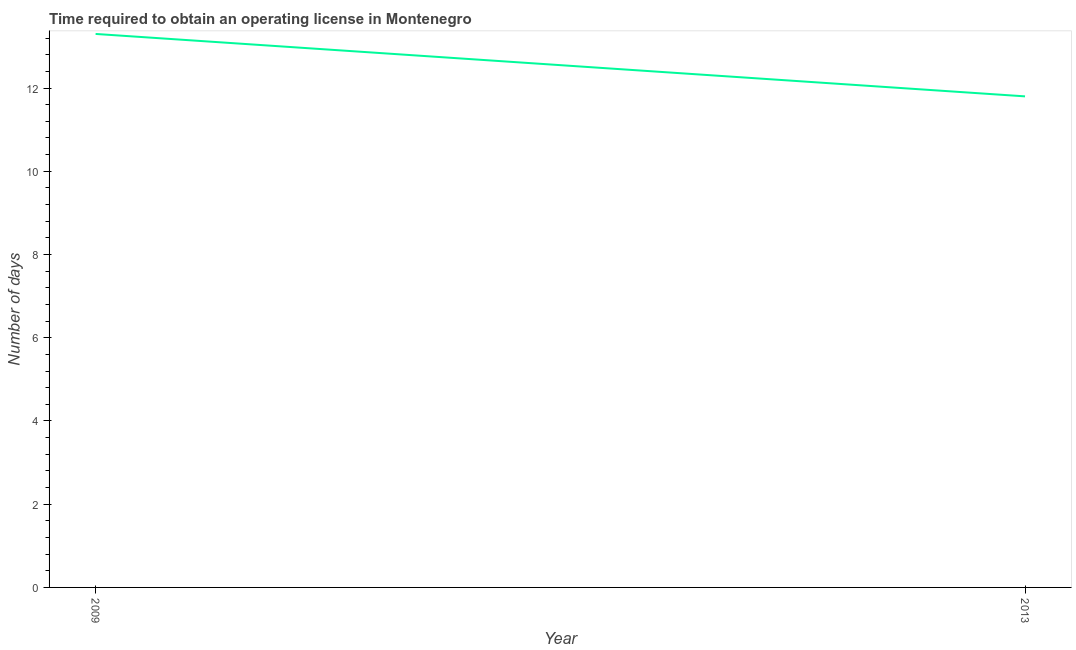What is the number of days to obtain operating license in 2013?
Your answer should be compact. 11.8. What is the sum of the number of days to obtain operating license?
Your answer should be compact. 25.1. What is the average number of days to obtain operating license per year?
Ensure brevity in your answer.  12.55. What is the median number of days to obtain operating license?
Your answer should be compact. 12.55. Do a majority of the years between 2013 and 2009 (inclusive) have number of days to obtain operating license greater than 6.4 days?
Your response must be concise. No. What is the ratio of the number of days to obtain operating license in 2009 to that in 2013?
Your response must be concise. 1.13. Is the number of days to obtain operating license in 2009 less than that in 2013?
Provide a short and direct response. No. In how many years, is the number of days to obtain operating license greater than the average number of days to obtain operating license taken over all years?
Offer a very short reply. 1. Does the number of days to obtain operating license monotonically increase over the years?
Your answer should be compact. No. How many lines are there?
Your answer should be very brief. 1. How many years are there in the graph?
Ensure brevity in your answer.  2. What is the difference between two consecutive major ticks on the Y-axis?
Keep it short and to the point. 2. Are the values on the major ticks of Y-axis written in scientific E-notation?
Offer a terse response. No. Does the graph contain grids?
Ensure brevity in your answer.  No. What is the title of the graph?
Give a very brief answer. Time required to obtain an operating license in Montenegro. What is the label or title of the Y-axis?
Your answer should be compact. Number of days. What is the Number of days of 2009?
Your answer should be very brief. 13.3. What is the ratio of the Number of days in 2009 to that in 2013?
Your response must be concise. 1.13. 